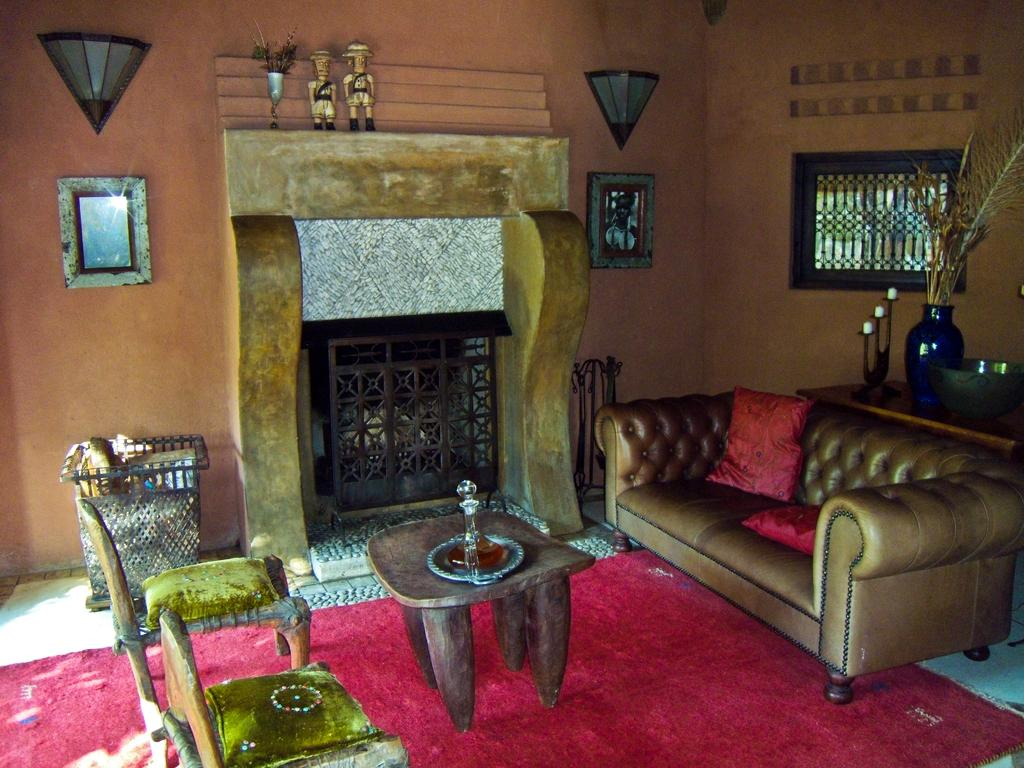How many chairs are in the image? There are two chairs in the image. What other furniture is present in the image? There is a sofa and a table in the image. What is the color of the carpet in the image? The carpet is red in color. What can be seen on the wall in the image? There is a frame on a wall in the image. How many sisters are sitting on the chairs in the image? There are no people, including sisters, present in the image. What type of hammer is used to hang the frame on the wall in the image? There is no hammer visible in the image, and the process of hanging the frame is not shown. 